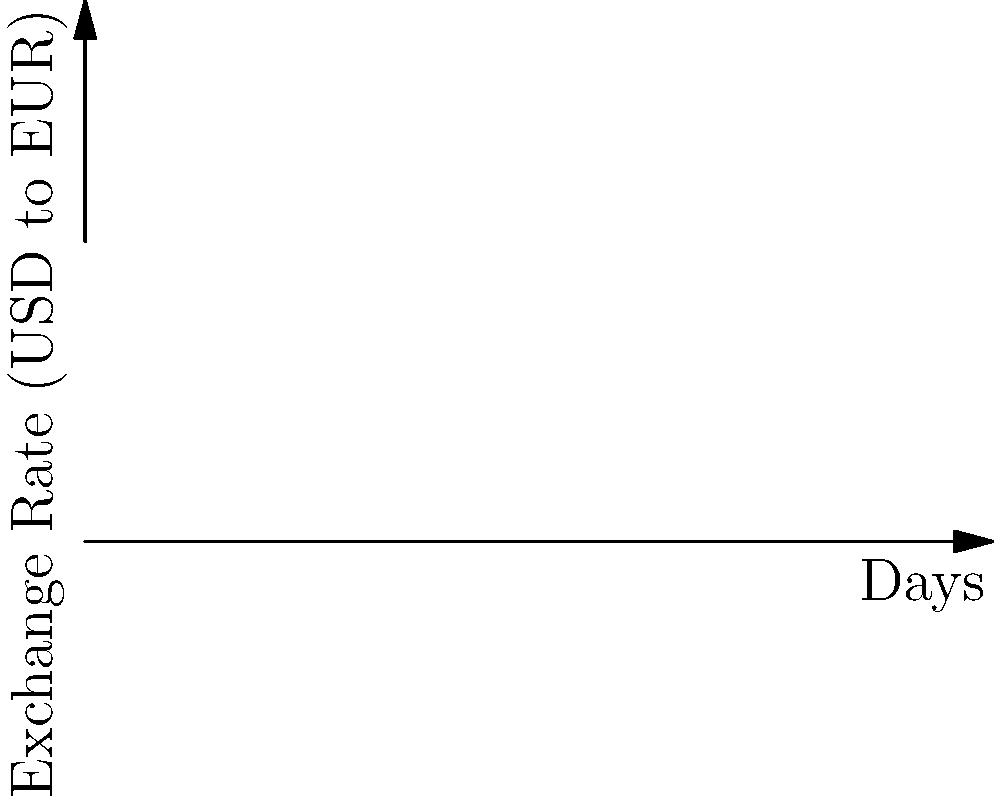As a travel blogger visiting Europe, you need to exchange USD for both EUR and GBP. The graph shows the exchange rates over 10 days. On day 5, you exchange $1000 USD to EUR at point A and another $1000 USD to GBP at point B. After your trip, you convert all unused foreign currency back to USD at the same rates. If you spent €600 and £500 during your trip, how much money in USD do you have left? Let's break this down step-by-step:

1. Find the exchange rates on day 5:
   USD to EUR (point A): $1.2 + 0.05 * 5 = 1.45$ EUR/USD
   USD to GBP (point B): $1.15 + 0.03 * 5 = 1.30$ GBP/USD

2. Calculate how much foreign currency you received:
   EUR: $1000 / 1.45 = 689.66$ EUR
   GBP: $1000 / 1.30 = 769.23$ GBP

3. Calculate unused foreign currency:
   EUR: $689.66 - 600 = 89.66$ EUR
   GBP: $769.23 - 500 = 269.23$ GBP

4. Convert unused foreign currency back to USD:
   EUR to USD: $89.66 * 1.45 = 130.01$ USD
   GBP to USD: $269.23 * 1.30 = 350.00$ USD

5. Sum up the total USD:
   $130.01 + 350.00 = 480.01$ USD

Therefore, you have $480.01 USD left after the trip.
Answer: $480.01 USD 